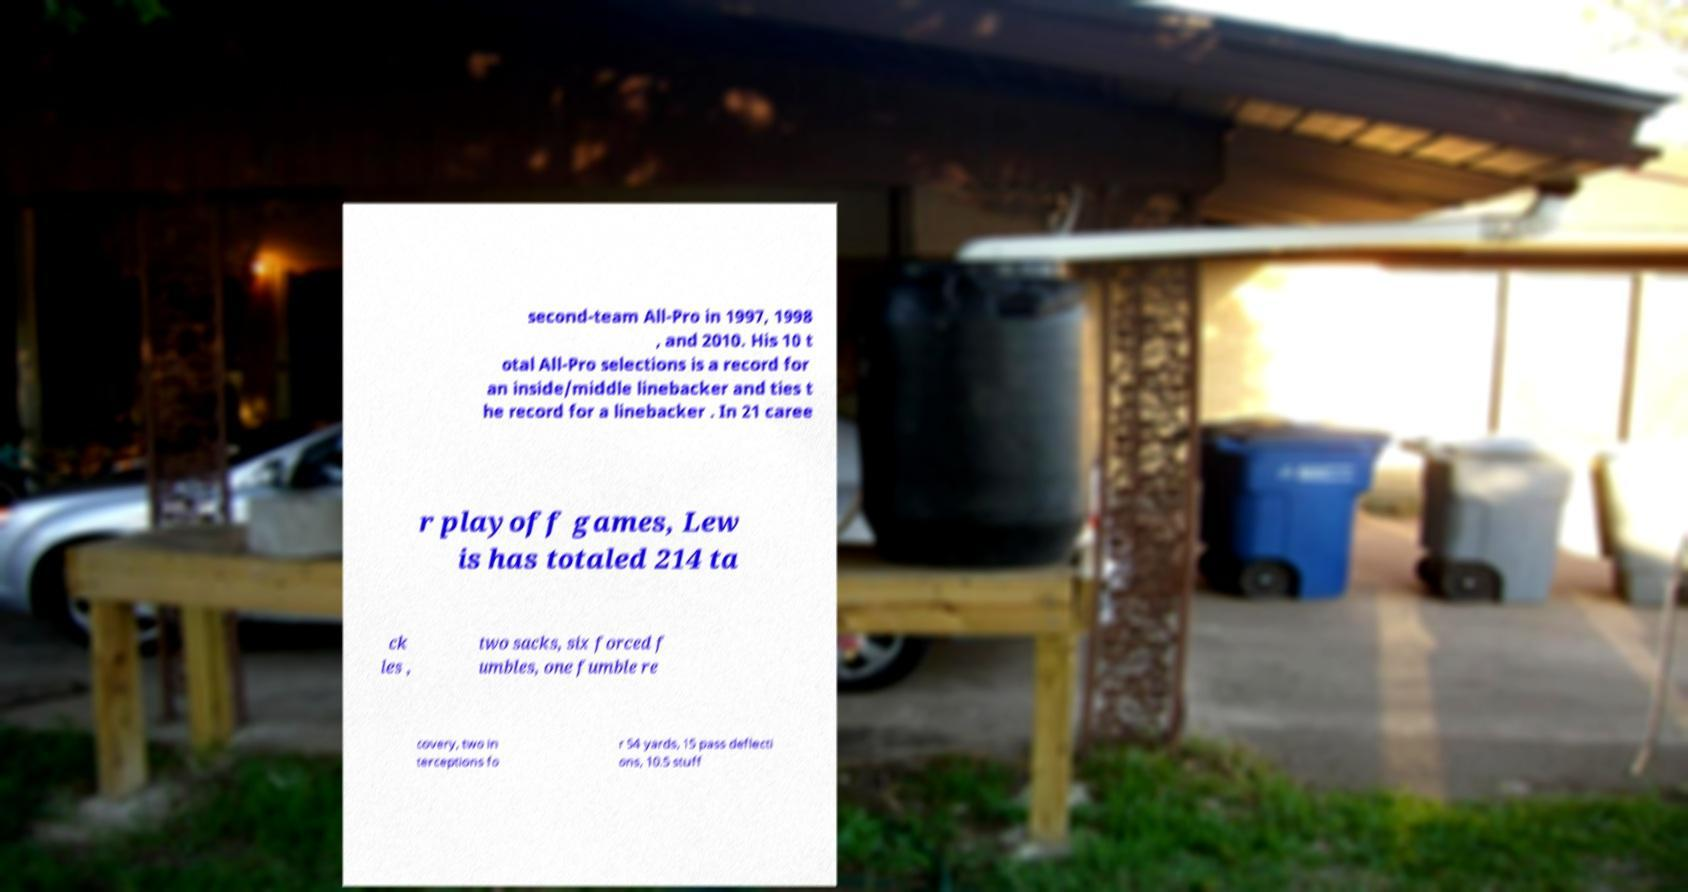Can you accurately transcribe the text from the provided image for me? second-team All-Pro in 1997, 1998 , and 2010. His 10 t otal All-Pro selections is a record for an inside/middle linebacker and ties t he record for a linebacker . In 21 caree r playoff games, Lew is has totaled 214 ta ck les , two sacks, six forced f umbles, one fumble re covery, two in terceptions fo r 54 yards, 15 pass deflecti ons, 10.5 stuff 